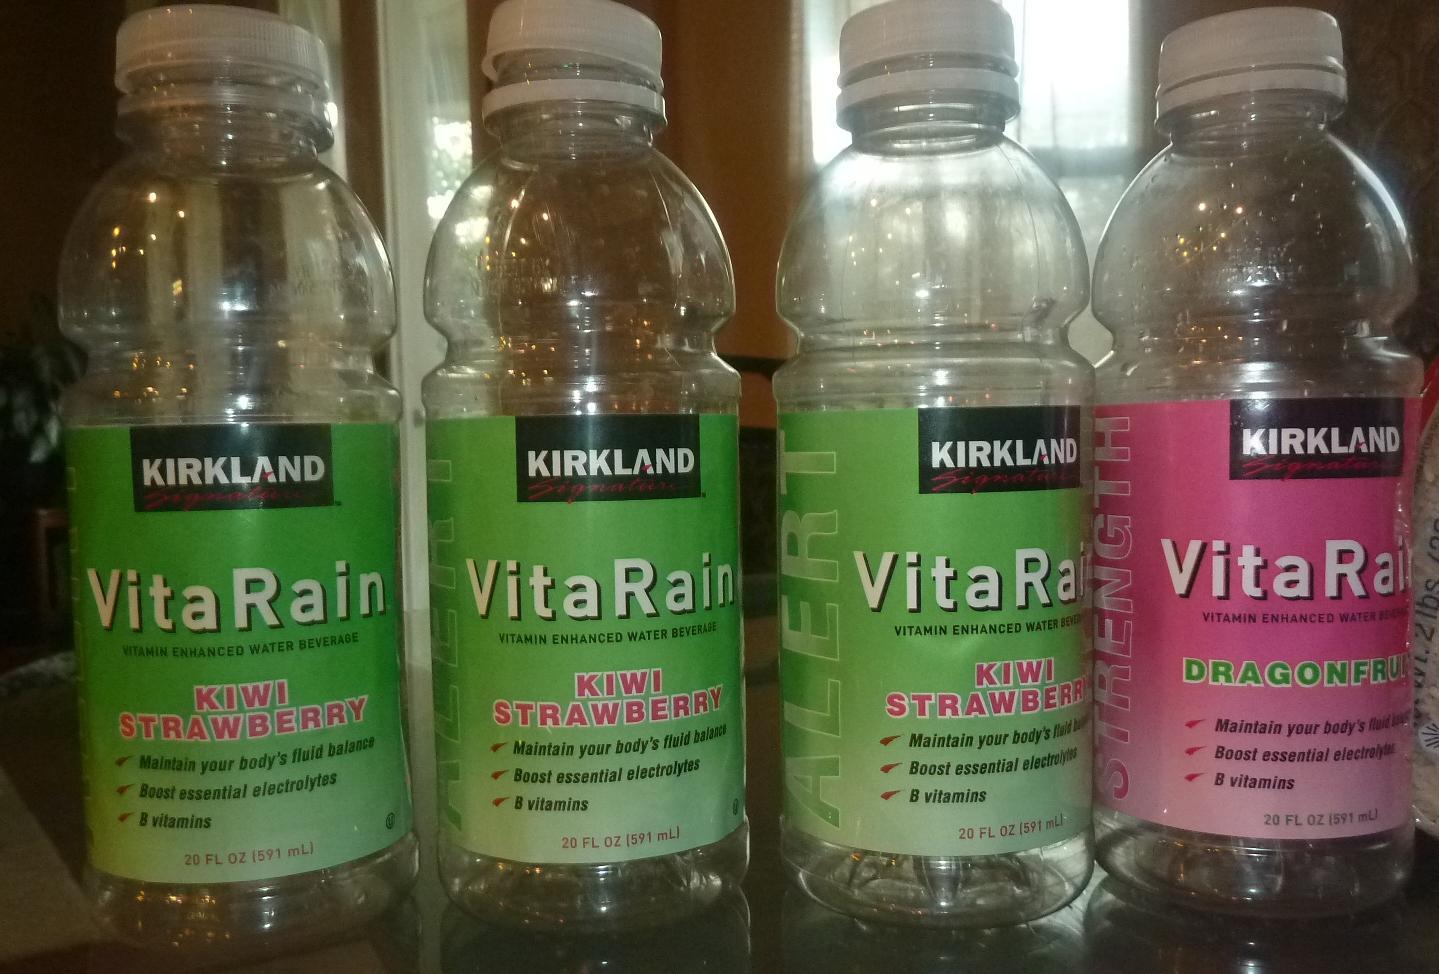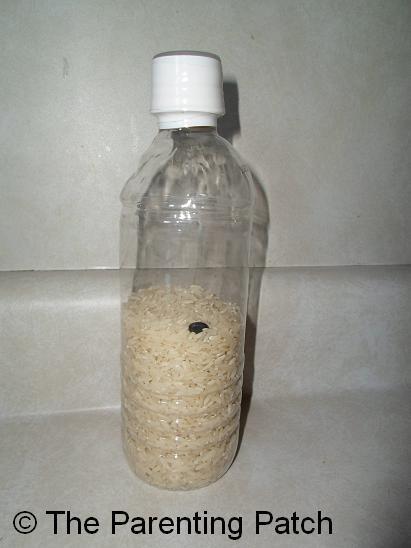The first image is the image on the left, the second image is the image on the right. Given the left and right images, does the statement "None of the bottles have labels." hold true? Answer yes or no. No. The first image is the image on the left, the second image is the image on the right. Analyze the images presented: Is the assertion "In one image, three empty bottles with no caps and glistening from a light source, are sitting in a triangle shaped arrangement." valid? Answer yes or no. No. 